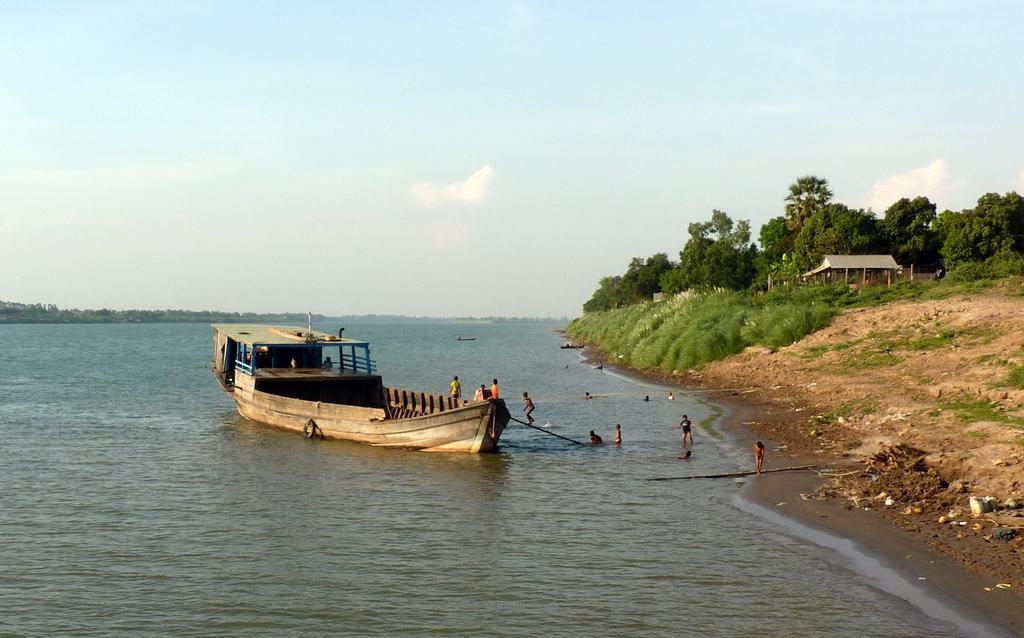Can you describe this image briefly? In this image I can see water. There are boats, there are few people, trees and plants. Also there is grass, a building and in the background there is sky. 